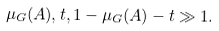Convert formula to latex. <formula><loc_0><loc_0><loc_500><loc_500>\mu _ { G } ( A ) , t , 1 - \mu _ { G } ( A ) - t \gg 1 .</formula> 